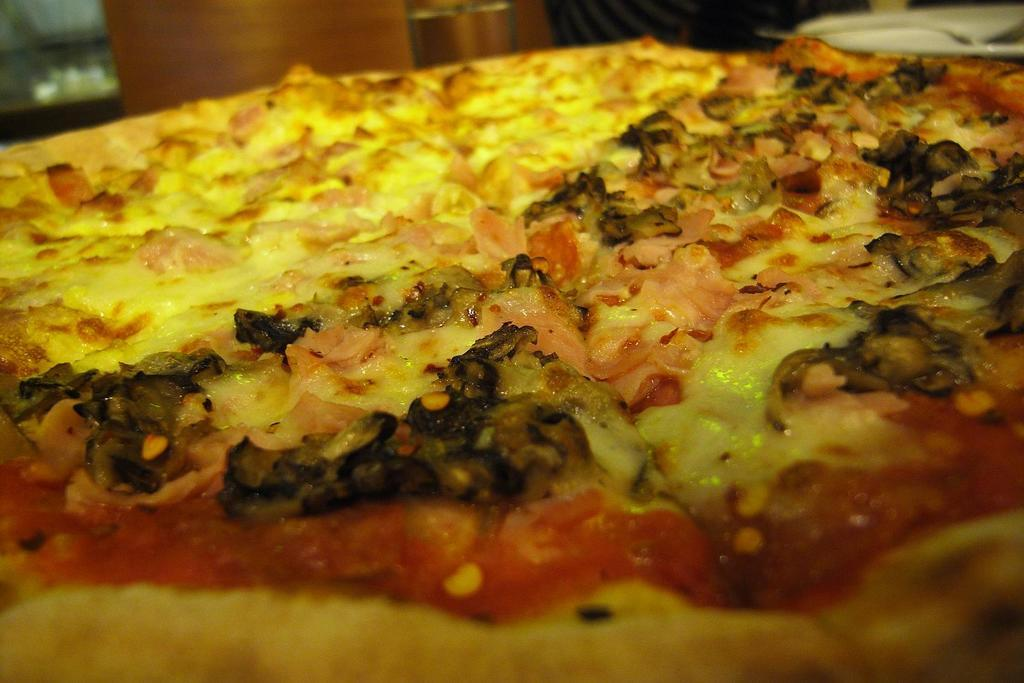What type of food is visible in the image? There is a pizza in the image. Can you describe the background of the image? The background of the image is blurred. What type of object can be seen in the background of the image? There is a wooden object in the background of the image. What type of underwear is visible on the pizza in the image? There is no underwear present on the pizza in the image. Can you describe the sofa in the image? There is no sofa present in the image. 